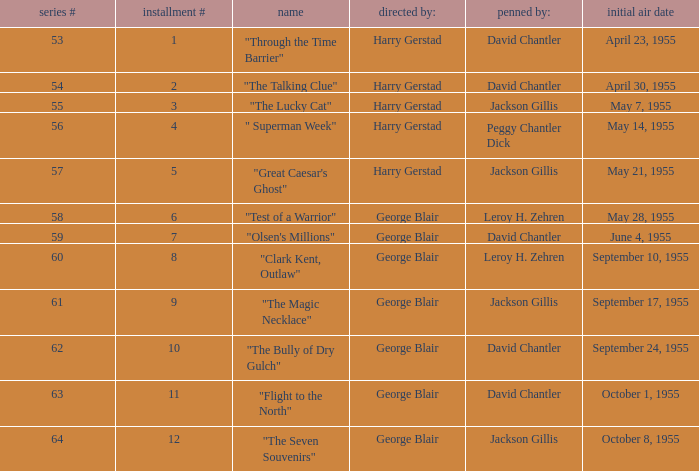When did season 9 originally air? September 17, 1955. 